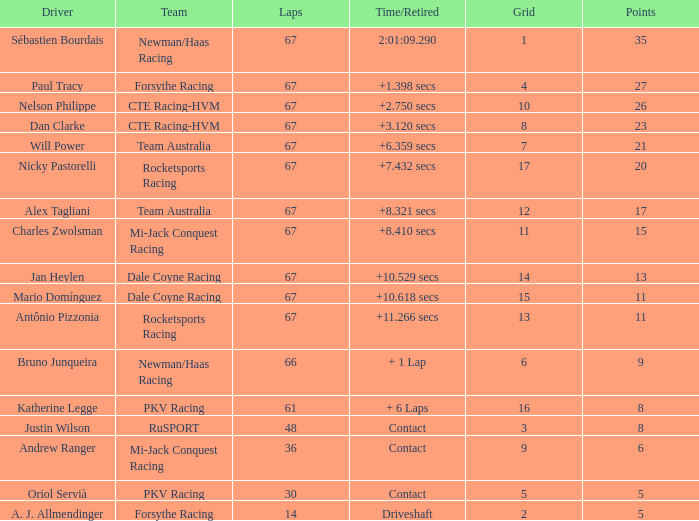How many average laps for Alex Tagliani with more than 17 points? None. 